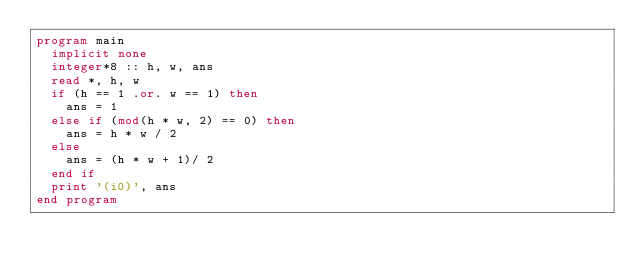Convert code to text. <code><loc_0><loc_0><loc_500><loc_500><_FORTRAN_>program main
  implicit none
  integer*8 :: h, w, ans
  read *, h, w
  if (h == 1 .or. w == 1) then
    ans = 1
  else if (mod(h * w, 2) == 0) then
    ans = h * w / 2 
  else
    ans = (h * w + 1)/ 2
  end if
  print '(i0)', ans
end program</code> 